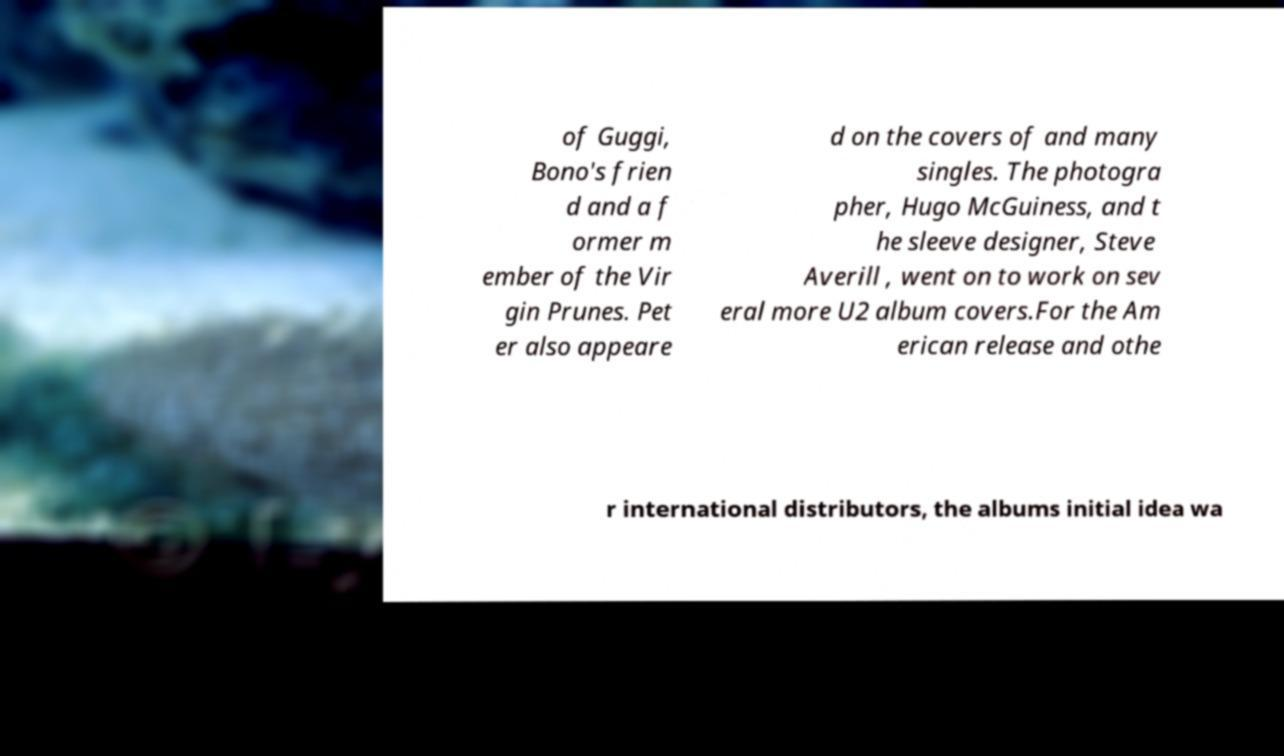Could you assist in decoding the text presented in this image and type it out clearly? of Guggi, Bono's frien d and a f ormer m ember of the Vir gin Prunes. Pet er also appeare d on the covers of and many singles. The photogra pher, Hugo McGuiness, and t he sleeve designer, Steve Averill , went on to work on sev eral more U2 album covers.For the Am erican release and othe r international distributors, the albums initial idea wa 